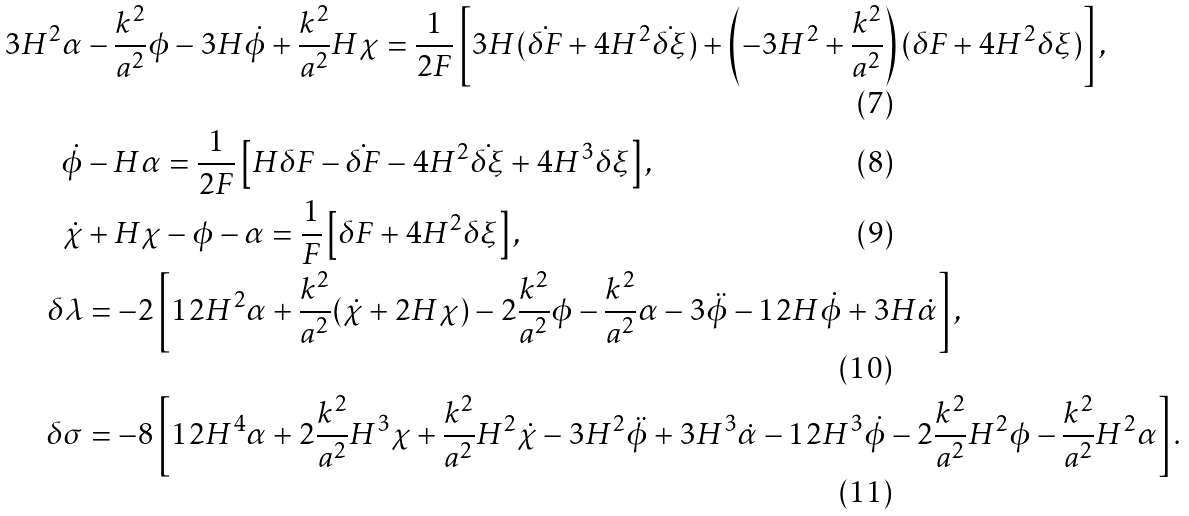Convert formula to latex. <formula><loc_0><loc_0><loc_500><loc_500>3 H ^ { 2 } \alpha & - \frac { k ^ { 2 } } { a ^ { 2 } } \phi - 3 H { \dot { \phi } } + \frac { k ^ { 2 } } { a ^ { 2 } } H \chi = \frac { 1 } { 2 F } \left [ 3 H ( { \dot { \delta F } } + 4 H ^ { 2 } { \dot { \delta \xi } } ) + \left ( - 3 H ^ { 2 } + \frac { k ^ { 2 } } { a ^ { 2 } } \right ) ( \delta F + 4 H ^ { 2 } \delta \xi ) \right ] , \\ { \dot { \phi } } & - H \alpha = \frac { 1 } { 2 F } \left [ H \delta F - { \dot { \delta F } } - 4 H ^ { 2 } { \dot { \delta \xi } } + 4 H ^ { 3 } \delta \xi \right ] , \\ { \dot { \chi } } & + H \chi - \phi - \alpha = \frac { 1 } { F } \left [ \delta F + 4 H ^ { 2 } \delta \xi \right ] , \\ \delta \lambda & = - 2 \left [ 1 2 H ^ { 2 } \alpha + \frac { k ^ { 2 } } { a ^ { 2 } } ( { \dot { \chi } } + 2 H \chi ) - 2 \frac { k ^ { 2 } } { a ^ { 2 } } \phi - \frac { k ^ { 2 } } { a ^ { 2 } } \alpha - 3 { \ddot { \phi } } - 1 2 H { \dot { \phi } } + 3 H { \dot { \alpha } } \right ] , \\ \delta \sigma & = - 8 \left [ 1 2 H ^ { 4 } \alpha + 2 \frac { k ^ { 2 } } { a ^ { 2 } } H ^ { 3 } \chi + \frac { k ^ { 2 } } { a ^ { 2 } } H ^ { 2 } { \dot { \chi } } - 3 H ^ { 2 } { \ddot { \phi } } + 3 H ^ { 3 } { \dot { \alpha } } - 1 2 H ^ { 3 } { \dot { \phi } } - 2 \frac { k ^ { 2 } } { a ^ { 2 } } H ^ { 2 } \phi - \frac { k ^ { 2 } } { a ^ { 2 } } H ^ { 2 } \alpha \right ] .</formula> 